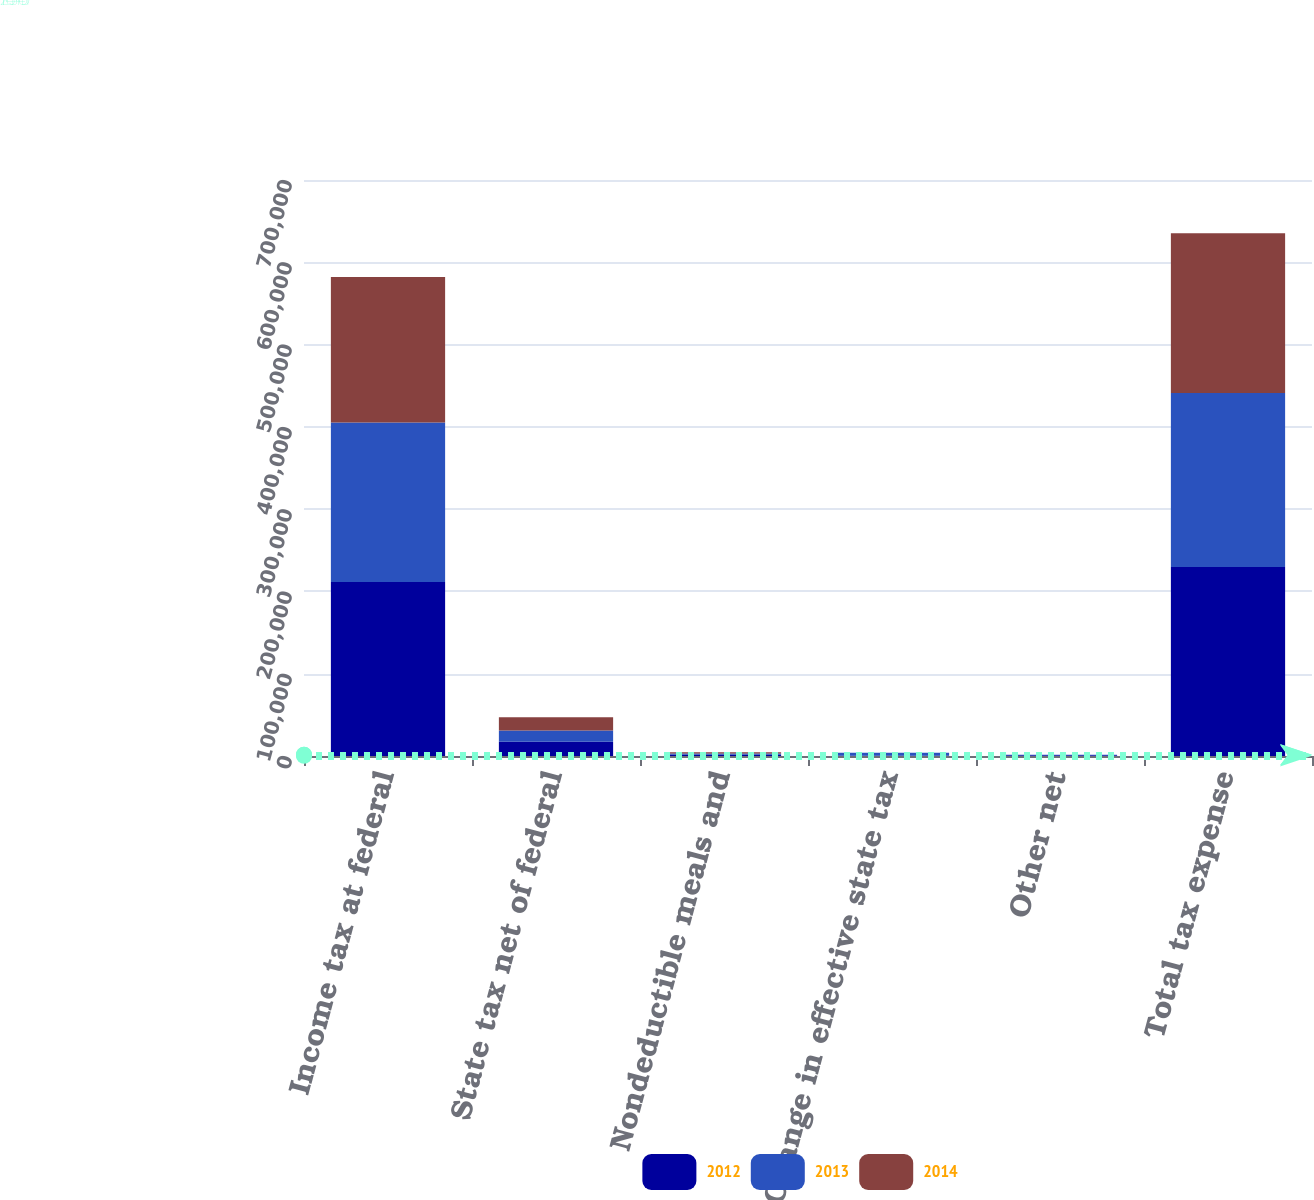<chart> <loc_0><loc_0><loc_500><loc_500><stacked_bar_chart><ecel><fcel>Income tax at federal<fcel>State tax net of federal<fcel>Nondeductible meals and<fcel>Change in effective state tax<fcel>Other net<fcel>Total tax expense<nl><fcel>2012<fcel>211610<fcel>17357<fcel>1395<fcel>256<fcel>809<fcel>229809<nl><fcel>2013<fcel>193749<fcel>13551<fcel>1543<fcel>3708<fcel>610<fcel>211186<nl><fcel>2014<fcel>176624<fcel>16191<fcel>1568<fcel>126<fcel>222<fcel>194287<nl></chart> 